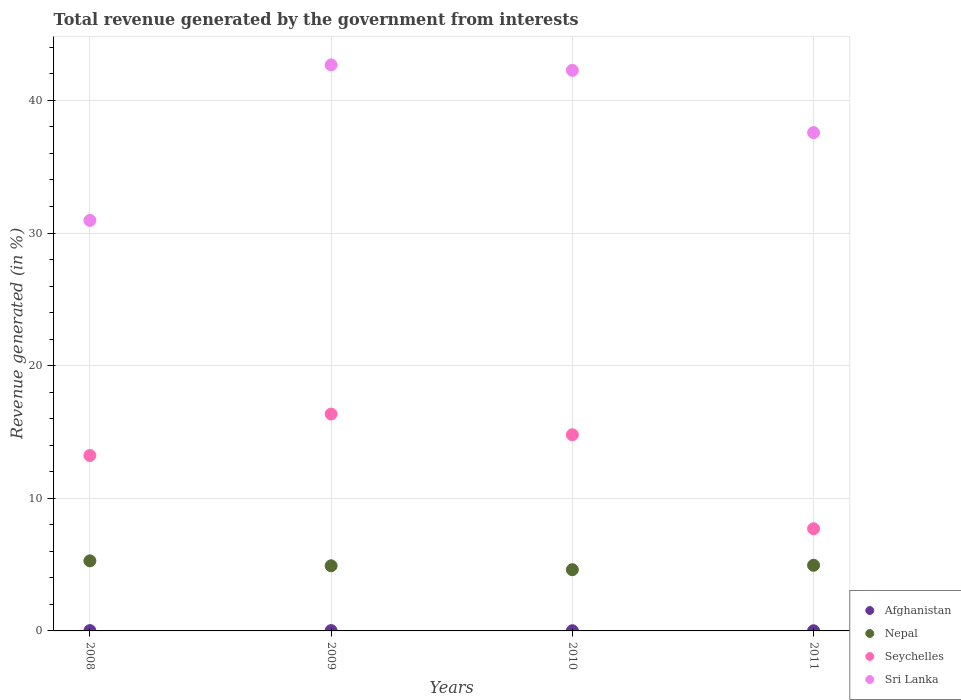Is the number of dotlines equal to the number of legend labels?
Ensure brevity in your answer.  Yes. What is the total revenue generated in Seychelles in 2010?
Offer a very short reply. 14.79. Across all years, what is the maximum total revenue generated in Sri Lanka?
Your response must be concise. 42.68. Across all years, what is the minimum total revenue generated in Sri Lanka?
Provide a short and direct response. 30.95. In which year was the total revenue generated in Nepal maximum?
Keep it short and to the point. 2008. What is the total total revenue generated in Seychelles in the graph?
Provide a succinct answer. 52.08. What is the difference between the total revenue generated in Nepal in 2010 and that in 2011?
Offer a terse response. -0.33. What is the difference between the total revenue generated in Seychelles in 2010 and the total revenue generated in Sri Lanka in 2008?
Provide a succinct answer. -16.16. What is the average total revenue generated in Seychelles per year?
Make the answer very short. 13.02. In the year 2008, what is the difference between the total revenue generated in Nepal and total revenue generated in Seychelles?
Ensure brevity in your answer.  -7.94. In how many years, is the total revenue generated in Seychelles greater than 8 %?
Your answer should be very brief. 3. What is the ratio of the total revenue generated in Nepal in 2010 to that in 2011?
Provide a short and direct response. 0.93. What is the difference between the highest and the second highest total revenue generated in Afghanistan?
Give a very brief answer. 0. What is the difference between the highest and the lowest total revenue generated in Seychelles?
Offer a terse response. 8.65. Is the sum of the total revenue generated in Sri Lanka in 2009 and 2010 greater than the maximum total revenue generated in Afghanistan across all years?
Offer a very short reply. Yes. Does the total revenue generated in Nepal monotonically increase over the years?
Provide a succinct answer. No. How many dotlines are there?
Offer a terse response. 4. How many years are there in the graph?
Provide a succinct answer. 4. How many legend labels are there?
Offer a terse response. 4. How are the legend labels stacked?
Offer a terse response. Vertical. What is the title of the graph?
Your answer should be compact. Total revenue generated by the government from interests. What is the label or title of the X-axis?
Give a very brief answer. Years. What is the label or title of the Y-axis?
Keep it short and to the point. Revenue generated (in %). What is the Revenue generated (in %) of Afghanistan in 2008?
Your answer should be very brief. 0.02. What is the Revenue generated (in %) in Nepal in 2008?
Your answer should be compact. 5.28. What is the Revenue generated (in %) in Seychelles in 2008?
Provide a succinct answer. 13.23. What is the Revenue generated (in %) in Sri Lanka in 2008?
Your answer should be compact. 30.95. What is the Revenue generated (in %) in Afghanistan in 2009?
Provide a succinct answer. 0.02. What is the Revenue generated (in %) of Nepal in 2009?
Make the answer very short. 4.91. What is the Revenue generated (in %) in Seychelles in 2009?
Provide a succinct answer. 16.35. What is the Revenue generated (in %) of Sri Lanka in 2009?
Give a very brief answer. 42.68. What is the Revenue generated (in %) of Afghanistan in 2010?
Make the answer very short. 0.01. What is the Revenue generated (in %) in Nepal in 2010?
Offer a terse response. 4.62. What is the Revenue generated (in %) of Seychelles in 2010?
Your response must be concise. 14.79. What is the Revenue generated (in %) of Sri Lanka in 2010?
Ensure brevity in your answer.  42.27. What is the Revenue generated (in %) in Afghanistan in 2011?
Give a very brief answer. 0.01. What is the Revenue generated (in %) of Nepal in 2011?
Provide a succinct answer. 4.95. What is the Revenue generated (in %) in Seychelles in 2011?
Give a very brief answer. 7.71. What is the Revenue generated (in %) of Sri Lanka in 2011?
Your response must be concise. 37.57. Across all years, what is the maximum Revenue generated (in %) of Afghanistan?
Make the answer very short. 0.02. Across all years, what is the maximum Revenue generated (in %) in Nepal?
Provide a short and direct response. 5.28. Across all years, what is the maximum Revenue generated (in %) in Seychelles?
Your answer should be compact. 16.35. Across all years, what is the maximum Revenue generated (in %) in Sri Lanka?
Keep it short and to the point. 42.68. Across all years, what is the minimum Revenue generated (in %) in Afghanistan?
Keep it short and to the point. 0.01. Across all years, what is the minimum Revenue generated (in %) of Nepal?
Offer a terse response. 4.62. Across all years, what is the minimum Revenue generated (in %) of Seychelles?
Provide a succinct answer. 7.71. Across all years, what is the minimum Revenue generated (in %) of Sri Lanka?
Your answer should be very brief. 30.95. What is the total Revenue generated (in %) of Afghanistan in the graph?
Offer a terse response. 0.07. What is the total Revenue generated (in %) of Nepal in the graph?
Offer a very short reply. 19.76. What is the total Revenue generated (in %) of Seychelles in the graph?
Provide a succinct answer. 52.08. What is the total Revenue generated (in %) in Sri Lanka in the graph?
Offer a very short reply. 153.47. What is the difference between the Revenue generated (in %) in Afghanistan in 2008 and that in 2009?
Your response must be concise. -0. What is the difference between the Revenue generated (in %) of Nepal in 2008 and that in 2009?
Your answer should be compact. 0.37. What is the difference between the Revenue generated (in %) in Seychelles in 2008 and that in 2009?
Provide a succinct answer. -3.13. What is the difference between the Revenue generated (in %) of Sri Lanka in 2008 and that in 2009?
Offer a very short reply. -11.73. What is the difference between the Revenue generated (in %) of Afghanistan in 2008 and that in 2010?
Offer a very short reply. 0.01. What is the difference between the Revenue generated (in %) of Nepal in 2008 and that in 2010?
Give a very brief answer. 0.67. What is the difference between the Revenue generated (in %) of Seychelles in 2008 and that in 2010?
Give a very brief answer. -1.56. What is the difference between the Revenue generated (in %) in Sri Lanka in 2008 and that in 2010?
Provide a succinct answer. -11.32. What is the difference between the Revenue generated (in %) in Afghanistan in 2008 and that in 2011?
Offer a terse response. 0.01. What is the difference between the Revenue generated (in %) in Nepal in 2008 and that in 2011?
Ensure brevity in your answer.  0.33. What is the difference between the Revenue generated (in %) of Seychelles in 2008 and that in 2011?
Offer a terse response. 5.52. What is the difference between the Revenue generated (in %) of Sri Lanka in 2008 and that in 2011?
Provide a short and direct response. -6.62. What is the difference between the Revenue generated (in %) in Afghanistan in 2009 and that in 2010?
Provide a succinct answer. 0.01. What is the difference between the Revenue generated (in %) of Nepal in 2009 and that in 2010?
Provide a short and direct response. 0.3. What is the difference between the Revenue generated (in %) of Seychelles in 2009 and that in 2010?
Keep it short and to the point. 1.56. What is the difference between the Revenue generated (in %) in Sri Lanka in 2009 and that in 2010?
Provide a short and direct response. 0.41. What is the difference between the Revenue generated (in %) in Afghanistan in 2009 and that in 2011?
Give a very brief answer. 0.01. What is the difference between the Revenue generated (in %) in Nepal in 2009 and that in 2011?
Give a very brief answer. -0.04. What is the difference between the Revenue generated (in %) in Seychelles in 2009 and that in 2011?
Provide a succinct answer. 8.65. What is the difference between the Revenue generated (in %) in Sri Lanka in 2009 and that in 2011?
Offer a terse response. 5.11. What is the difference between the Revenue generated (in %) of Afghanistan in 2010 and that in 2011?
Offer a terse response. 0. What is the difference between the Revenue generated (in %) in Nepal in 2010 and that in 2011?
Keep it short and to the point. -0.33. What is the difference between the Revenue generated (in %) of Seychelles in 2010 and that in 2011?
Give a very brief answer. 7.09. What is the difference between the Revenue generated (in %) of Sri Lanka in 2010 and that in 2011?
Your answer should be very brief. 4.7. What is the difference between the Revenue generated (in %) of Afghanistan in 2008 and the Revenue generated (in %) of Nepal in 2009?
Offer a very short reply. -4.89. What is the difference between the Revenue generated (in %) in Afghanistan in 2008 and the Revenue generated (in %) in Seychelles in 2009?
Ensure brevity in your answer.  -16.33. What is the difference between the Revenue generated (in %) in Afghanistan in 2008 and the Revenue generated (in %) in Sri Lanka in 2009?
Provide a succinct answer. -42.66. What is the difference between the Revenue generated (in %) of Nepal in 2008 and the Revenue generated (in %) of Seychelles in 2009?
Provide a short and direct response. -11.07. What is the difference between the Revenue generated (in %) of Nepal in 2008 and the Revenue generated (in %) of Sri Lanka in 2009?
Provide a short and direct response. -37.4. What is the difference between the Revenue generated (in %) in Seychelles in 2008 and the Revenue generated (in %) in Sri Lanka in 2009?
Your answer should be very brief. -29.45. What is the difference between the Revenue generated (in %) of Afghanistan in 2008 and the Revenue generated (in %) of Nepal in 2010?
Keep it short and to the point. -4.59. What is the difference between the Revenue generated (in %) in Afghanistan in 2008 and the Revenue generated (in %) in Seychelles in 2010?
Provide a short and direct response. -14.77. What is the difference between the Revenue generated (in %) of Afghanistan in 2008 and the Revenue generated (in %) of Sri Lanka in 2010?
Give a very brief answer. -42.24. What is the difference between the Revenue generated (in %) of Nepal in 2008 and the Revenue generated (in %) of Seychelles in 2010?
Your response must be concise. -9.51. What is the difference between the Revenue generated (in %) in Nepal in 2008 and the Revenue generated (in %) in Sri Lanka in 2010?
Ensure brevity in your answer.  -36.98. What is the difference between the Revenue generated (in %) of Seychelles in 2008 and the Revenue generated (in %) of Sri Lanka in 2010?
Keep it short and to the point. -29.04. What is the difference between the Revenue generated (in %) of Afghanistan in 2008 and the Revenue generated (in %) of Nepal in 2011?
Ensure brevity in your answer.  -4.93. What is the difference between the Revenue generated (in %) of Afghanistan in 2008 and the Revenue generated (in %) of Seychelles in 2011?
Ensure brevity in your answer.  -7.68. What is the difference between the Revenue generated (in %) in Afghanistan in 2008 and the Revenue generated (in %) in Sri Lanka in 2011?
Your answer should be very brief. -37.55. What is the difference between the Revenue generated (in %) of Nepal in 2008 and the Revenue generated (in %) of Seychelles in 2011?
Offer a terse response. -2.42. What is the difference between the Revenue generated (in %) of Nepal in 2008 and the Revenue generated (in %) of Sri Lanka in 2011?
Your answer should be very brief. -32.29. What is the difference between the Revenue generated (in %) of Seychelles in 2008 and the Revenue generated (in %) of Sri Lanka in 2011?
Offer a terse response. -24.34. What is the difference between the Revenue generated (in %) in Afghanistan in 2009 and the Revenue generated (in %) in Nepal in 2010?
Offer a terse response. -4.59. What is the difference between the Revenue generated (in %) of Afghanistan in 2009 and the Revenue generated (in %) of Seychelles in 2010?
Provide a succinct answer. -14.77. What is the difference between the Revenue generated (in %) of Afghanistan in 2009 and the Revenue generated (in %) of Sri Lanka in 2010?
Provide a succinct answer. -42.24. What is the difference between the Revenue generated (in %) of Nepal in 2009 and the Revenue generated (in %) of Seychelles in 2010?
Give a very brief answer. -9.88. What is the difference between the Revenue generated (in %) in Nepal in 2009 and the Revenue generated (in %) in Sri Lanka in 2010?
Your response must be concise. -37.36. What is the difference between the Revenue generated (in %) of Seychelles in 2009 and the Revenue generated (in %) of Sri Lanka in 2010?
Your answer should be compact. -25.91. What is the difference between the Revenue generated (in %) of Afghanistan in 2009 and the Revenue generated (in %) of Nepal in 2011?
Provide a short and direct response. -4.93. What is the difference between the Revenue generated (in %) of Afghanistan in 2009 and the Revenue generated (in %) of Seychelles in 2011?
Provide a short and direct response. -7.68. What is the difference between the Revenue generated (in %) in Afghanistan in 2009 and the Revenue generated (in %) in Sri Lanka in 2011?
Ensure brevity in your answer.  -37.55. What is the difference between the Revenue generated (in %) in Nepal in 2009 and the Revenue generated (in %) in Seychelles in 2011?
Your answer should be very brief. -2.79. What is the difference between the Revenue generated (in %) of Nepal in 2009 and the Revenue generated (in %) of Sri Lanka in 2011?
Keep it short and to the point. -32.66. What is the difference between the Revenue generated (in %) of Seychelles in 2009 and the Revenue generated (in %) of Sri Lanka in 2011?
Make the answer very short. -21.22. What is the difference between the Revenue generated (in %) of Afghanistan in 2010 and the Revenue generated (in %) of Nepal in 2011?
Ensure brevity in your answer.  -4.94. What is the difference between the Revenue generated (in %) of Afghanistan in 2010 and the Revenue generated (in %) of Seychelles in 2011?
Your response must be concise. -7.69. What is the difference between the Revenue generated (in %) of Afghanistan in 2010 and the Revenue generated (in %) of Sri Lanka in 2011?
Your answer should be very brief. -37.56. What is the difference between the Revenue generated (in %) in Nepal in 2010 and the Revenue generated (in %) in Seychelles in 2011?
Provide a succinct answer. -3.09. What is the difference between the Revenue generated (in %) in Nepal in 2010 and the Revenue generated (in %) in Sri Lanka in 2011?
Make the answer very short. -32.96. What is the difference between the Revenue generated (in %) in Seychelles in 2010 and the Revenue generated (in %) in Sri Lanka in 2011?
Your answer should be very brief. -22.78. What is the average Revenue generated (in %) in Afghanistan per year?
Offer a very short reply. 0.02. What is the average Revenue generated (in %) of Nepal per year?
Make the answer very short. 4.94. What is the average Revenue generated (in %) in Seychelles per year?
Make the answer very short. 13.02. What is the average Revenue generated (in %) in Sri Lanka per year?
Ensure brevity in your answer.  38.37. In the year 2008, what is the difference between the Revenue generated (in %) of Afghanistan and Revenue generated (in %) of Nepal?
Offer a terse response. -5.26. In the year 2008, what is the difference between the Revenue generated (in %) in Afghanistan and Revenue generated (in %) in Seychelles?
Your answer should be compact. -13.2. In the year 2008, what is the difference between the Revenue generated (in %) of Afghanistan and Revenue generated (in %) of Sri Lanka?
Your response must be concise. -30.93. In the year 2008, what is the difference between the Revenue generated (in %) of Nepal and Revenue generated (in %) of Seychelles?
Your answer should be compact. -7.94. In the year 2008, what is the difference between the Revenue generated (in %) of Nepal and Revenue generated (in %) of Sri Lanka?
Provide a short and direct response. -25.67. In the year 2008, what is the difference between the Revenue generated (in %) in Seychelles and Revenue generated (in %) in Sri Lanka?
Provide a succinct answer. -17.72. In the year 2009, what is the difference between the Revenue generated (in %) in Afghanistan and Revenue generated (in %) in Nepal?
Give a very brief answer. -4.89. In the year 2009, what is the difference between the Revenue generated (in %) of Afghanistan and Revenue generated (in %) of Seychelles?
Your answer should be very brief. -16.33. In the year 2009, what is the difference between the Revenue generated (in %) in Afghanistan and Revenue generated (in %) in Sri Lanka?
Give a very brief answer. -42.66. In the year 2009, what is the difference between the Revenue generated (in %) of Nepal and Revenue generated (in %) of Seychelles?
Ensure brevity in your answer.  -11.44. In the year 2009, what is the difference between the Revenue generated (in %) of Nepal and Revenue generated (in %) of Sri Lanka?
Offer a very short reply. -37.77. In the year 2009, what is the difference between the Revenue generated (in %) of Seychelles and Revenue generated (in %) of Sri Lanka?
Ensure brevity in your answer.  -26.33. In the year 2010, what is the difference between the Revenue generated (in %) in Afghanistan and Revenue generated (in %) in Nepal?
Provide a short and direct response. -4.6. In the year 2010, what is the difference between the Revenue generated (in %) of Afghanistan and Revenue generated (in %) of Seychelles?
Your answer should be compact. -14.78. In the year 2010, what is the difference between the Revenue generated (in %) in Afghanistan and Revenue generated (in %) in Sri Lanka?
Your response must be concise. -42.25. In the year 2010, what is the difference between the Revenue generated (in %) in Nepal and Revenue generated (in %) in Seychelles?
Give a very brief answer. -10.18. In the year 2010, what is the difference between the Revenue generated (in %) of Nepal and Revenue generated (in %) of Sri Lanka?
Ensure brevity in your answer.  -37.65. In the year 2010, what is the difference between the Revenue generated (in %) in Seychelles and Revenue generated (in %) in Sri Lanka?
Provide a succinct answer. -27.48. In the year 2011, what is the difference between the Revenue generated (in %) of Afghanistan and Revenue generated (in %) of Nepal?
Your answer should be compact. -4.94. In the year 2011, what is the difference between the Revenue generated (in %) of Afghanistan and Revenue generated (in %) of Seychelles?
Your answer should be compact. -7.69. In the year 2011, what is the difference between the Revenue generated (in %) in Afghanistan and Revenue generated (in %) in Sri Lanka?
Give a very brief answer. -37.56. In the year 2011, what is the difference between the Revenue generated (in %) in Nepal and Revenue generated (in %) in Seychelles?
Provide a short and direct response. -2.76. In the year 2011, what is the difference between the Revenue generated (in %) of Nepal and Revenue generated (in %) of Sri Lanka?
Provide a succinct answer. -32.62. In the year 2011, what is the difference between the Revenue generated (in %) in Seychelles and Revenue generated (in %) in Sri Lanka?
Provide a succinct answer. -29.87. What is the ratio of the Revenue generated (in %) of Afghanistan in 2008 to that in 2009?
Give a very brief answer. 0.94. What is the ratio of the Revenue generated (in %) in Nepal in 2008 to that in 2009?
Make the answer very short. 1.08. What is the ratio of the Revenue generated (in %) in Seychelles in 2008 to that in 2009?
Your response must be concise. 0.81. What is the ratio of the Revenue generated (in %) of Sri Lanka in 2008 to that in 2009?
Keep it short and to the point. 0.73. What is the ratio of the Revenue generated (in %) of Afghanistan in 2008 to that in 2010?
Offer a terse response. 1.6. What is the ratio of the Revenue generated (in %) in Nepal in 2008 to that in 2010?
Provide a succinct answer. 1.14. What is the ratio of the Revenue generated (in %) of Seychelles in 2008 to that in 2010?
Provide a succinct answer. 0.89. What is the ratio of the Revenue generated (in %) in Sri Lanka in 2008 to that in 2010?
Make the answer very short. 0.73. What is the ratio of the Revenue generated (in %) of Afghanistan in 2008 to that in 2011?
Keep it short and to the point. 1.97. What is the ratio of the Revenue generated (in %) of Nepal in 2008 to that in 2011?
Provide a short and direct response. 1.07. What is the ratio of the Revenue generated (in %) of Seychelles in 2008 to that in 2011?
Provide a succinct answer. 1.72. What is the ratio of the Revenue generated (in %) in Sri Lanka in 2008 to that in 2011?
Offer a very short reply. 0.82. What is the ratio of the Revenue generated (in %) of Afghanistan in 2009 to that in 2010?
Ensure brevity in your answer.  1.7. What is the ratio of the Revenue generated (in %) of Nepal in 2009 to that in 2010?
Give a very brief answer. 1.06. What is the ratio of the Revenue generated (in %) of Seychelles in 2009 to that in 2010?
Your answer should be very brief. 1.11. What is the ratio of the Revenue generated (in %) in Sri Lanka in 2009 to that in 2010?
Your answer should be compact. 1.01. What is the ratio of the Revenue generated (in %) of Afghanistan in 2009 to that in 2011?
Your response must be concise. 2.09. What is the ratio of the Revenue generated (in %) of Nepal in 2009 to that in 2011?
Offer a very short reply. 0.99. What is the ratio of the Revenue generated (in %) of Seychelles in 2009 to that in 2011?
Provide a succinct answer. 2.12. What is the ratio of the Revenue generated (in %) of Sri Lanka in 2009 to that in 2011?
Offer a terse response. 1.14. What is the ratio of the Revenue generated (in %) of Afghanistan in 2010 to that in 2011?
Ensure brevity in your answer.  1.24. What is the ratio of the Revenue generated (in %) in Nepal in 2010 to that in 2011?
Offer a terse response. 0.93. What is the ratio of the Revenue generated (in %) of Seychelles in 2010 to that in 2011?
Provide a succinct answer. 1.92. What is the ratio of the Revenue generated (in %) of Sri Lanka in 2010 to that in 2011?
Your answer should be very brief. 1.12. What is the difference between the highest and the second highest Revenue generated (in %) in Afghanistan?
Keep it short and to the point. 0. What is the difference between the highest and the second highest Revenue generated (in %) in Nepal?
Keep it short and to the point. 0.33. What is the difference between the highest and the second highest Revenue generated (in %) in Seychelles?
Provide a succinct answer. 1.56. What is the difference between the highest and the second highest Revenue generated (in %) in Sri Lanka?
Your answer should be compact. 0.41. What is the difference between the highest and the lowest Revenue generated (in %) in Afghanistan?
Your answer should be compact. 0.01. What is the difference between the highest and the lowest Revenue generated (in %) in Nepal?
Your response must be concise. 0.67. What is the difference between the highest and the lowest Revenue generated (in %) in Seychelles?
Provide a succinct answer. 8.65. What is the difference between the highest and the lowest Revenue generated (in %) in Sri Lanka?
Keep it short and to the point. 11.73. 